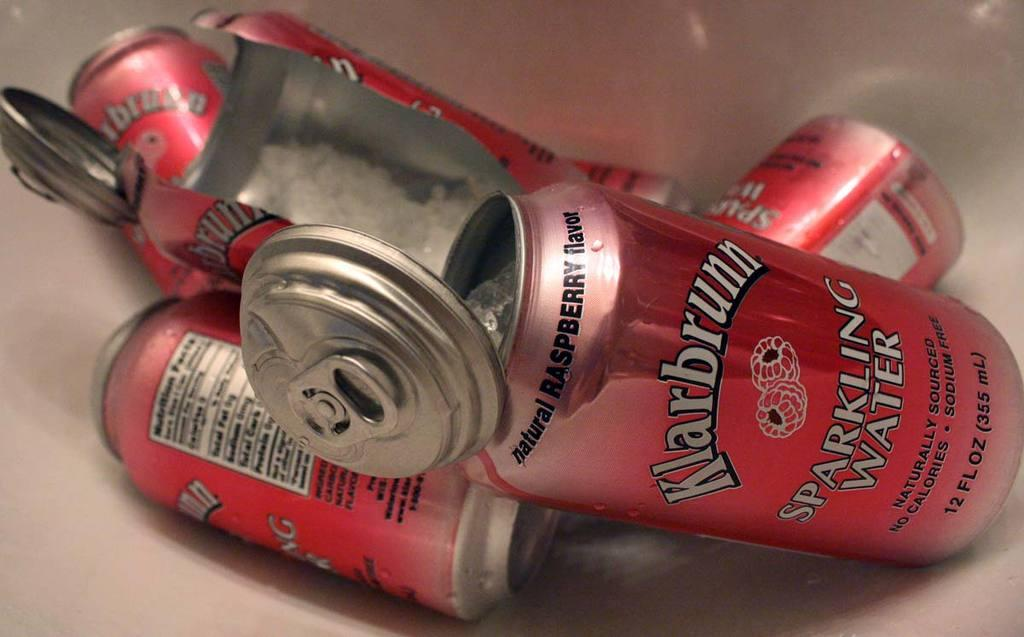<image>
Describe the image concisely. A small pile of red sparkling water cans are loosely stacked on top of each other. 